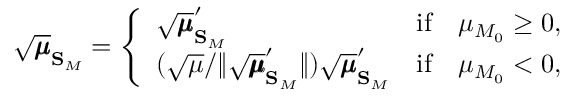Convert formula to latex. <formula><loc_0><loc_0><loc_500><loc_500>\sqrt { \pm b { \mu } } _ { S _ { M } } = \left \{ \begin{array} { l l } { \sqrt { \pm b { \mu } } _ { S _ { M } } ^ { \prime } } & { i f \quad \mu _ { M _ { 0 } } \geq 0 , } \\ { ( \sqrt { \mu } / \| \sqrt { \pm b { \mu } } _ { S _ { M } } ^ { \prime } \| ) \sqrt { \pm b { \mu } } _ { S _ { M } } ^ { \prime } } & { i f \quad \mu _ { M _ { 0 } } < 0 , } \end{array}</formula> 